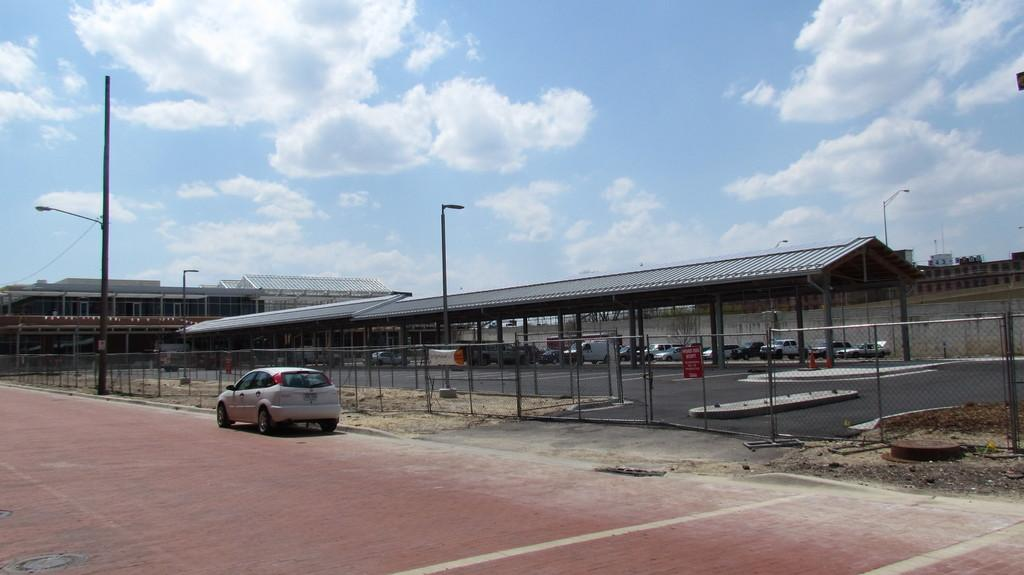What can be seen on the road in the image? There are fleets of vehicles on the road in the image. What type of barrier is present in the image? There is a fence in the image. What structures are present to provide illumination in the image? There are light poles in the image. What type of small structure can be seen in the image? There is a shed in the image. What type of man-made structures are visible in the image? There are buildings in the image. What part of the natural environment is visible in the image? The sky is visible in the image. What time of day is it in the image, considering the presence of the parent and the afternoon? There is no mention of a parent or afternoon in the image, so it is not possible to determine the time of day based on that information. 